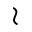<formula> <loc_0><loc_0><loc_500><loc_500>\wr</formula> 